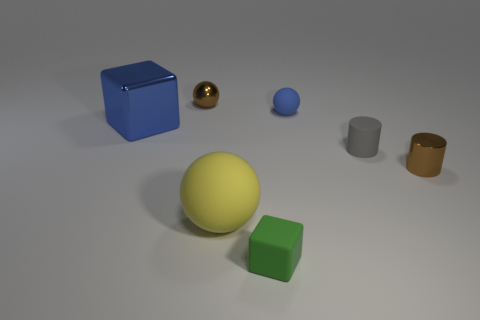Is the number of large things less than the number of brown spheres?
Offer a very short reply. No. Does the metallic ball have the same color as the metallic cylinder?
Give a very brief answer. Yes. Is the number of big blue metallic cubes greater than the number of rubber objects?
Your response must be concise. No. What number of other objects are there of the same color as the metal cylinder?
Offer a very short reply. 1. How many brown metal balls are right of the brown object behind the big blue metallic block?
Your response must be concise. 0. Are there any metal cylinders to the right of the small gray thing?
Give a very brief answer. Yes. What is the shape of the tiny thing that is left of the rubber object in front of the big yellow thing?
Provide a succinct answer. Sphere. Are there fewer tiny green rubber things on the right side of the small green cube than gray rubber cylinders that are in front of the small metal ball?
Offer a terse response. Yes. There is a small thing that is the same shape as the large blue metal object; what color is it?
Your answer should be very brief. Green. What number of objects are both in front of the blue matte sphere and to the left of the yellow rubber ball?
Ensure brevity in your answer.  1. 